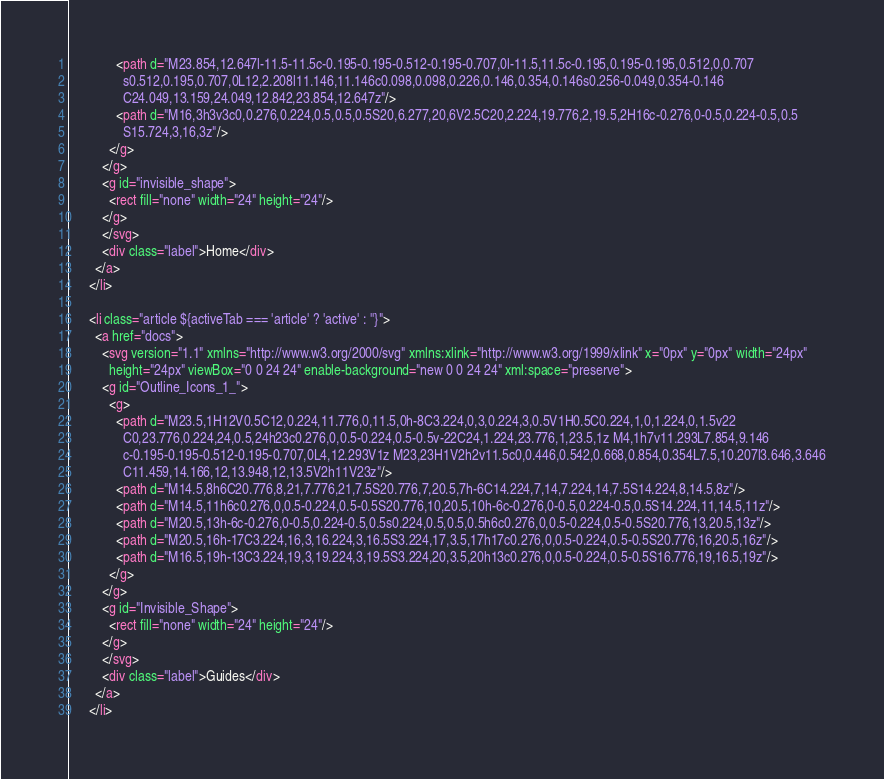<code> <loc_0><loc_0><loc_500><loc_500><_HTML_>              <path d="M23.854,12.647l-11.5-11.5c-0.195-0.195-0.512-0.195-0.707,0l-11.5,11.5c-0.195,0.195-0.195,0.512,0,0.707
                s0.512,0.195,0.707,0L12,2.208l11.146,11.146c0.098,0.098,0.226,0.146,0.354,0.146s0.256-0.049,0.354-0.146
                C24.049,13.159,24.049,12.842,23.854,12.647z"/>
              <path d="M16,3h3v3c0,0.276,0.224,0.5,0.5,0.5S20,6.277,20,6V2.5C20,2.224,19.776,2,19.5,2H16c-0.276,0-0.5,0.224-0.5,0.5
                S15.724,3,16,3z"/>
            </g>
          </g>
          <g id="invisible_shape">
            <rect fill="none" width="24" height="24"/>
          </g>
          </svg>
          <div class="label">Home</div>
        </a>
      </li>

      <li class="article ${activeTab === 'article' ? 'active' : ''}">
        <a href="docs">
          <svg version="1.1" xmlns="http://www.w3.org/2000/svg" xmlns:xlink="http://www.w3.org/1999/xlink" x="0px" y="0px" width="24px"
            height="24px" viewBox="0 0 24 24" enable-background="new 0 0 24 24" xml:space="preserve">
          <g id="Outline_Icons_1_">
            <g>
              <path d="M23.5,1H12V0.5C12,0.224,11.776,0,11.5,0h-8C3.224,0,3,0.224,3,0.5V1H0.5C0.224,1,0,1.224,0,1.5v22
                C0,23.776,0.224,24,0.5,24h23c0.276,0,0.5-0.224,0.5-0.5v-22C24,1.224,23.776,1,23.5,1z M4,1h7v11.293L7.854,9.146
                c-0.195-0.195-0.512-0.195-0.707,0L4,12.293V1z M23,23H1V2h2v11.5c0,0.446,0.542,0.668,0.854,0.354L7.5,10.207l3.646,3.646
                C11.459,14.166,12,13.948,12,13.5V2h11V23z"/>
              <path d="M14.5,8h6C20.776,8,21,7.776,21,7.5S20.776,7,20.5,7h-6C14.224,7,14,7.224,14,7.5S14.224,8,14.5,8z"/>
              <path d="M14.5,11h6c0.276,0,0.5-0.224,0.5-0.5S20.776,10,20.5,10h-6c-0.276,0-0.5,0.224-0.5,0.5S14.224,11,14.5,11z"/>
              <path d="M20.5,13h-6c-0.276,0-0.5,0.224-0.5,0.5s0.224,0.5,0.5,0.5h6c0.276,0,0.5-0.224,0.5-0.5S20.776,13,20.5,13z"/>
              <path d="M20.5,16h-17C3.224,16,3,16.224,3,16.5S3.224,17,3.5,17h17c0.276,0,0.5-0.224,0.5-0.5S20.776,16,20.5,16z"/>
              <path d="M16.5,19h-13C3.224,19,3,19.224,3,19.5S3.224,20,3.5,20h13c0.276,0,0.5-0.224,0.5-0.5S16.776,19,16.5,19z"/>
            </g>
          </g>
          <g id="Invisible_Shape">
            <rect fill="none" width="24" height="24"/>
          </g>
          </svg>
          <div class="label">Guides</div>
        </a>
      </li>
</code> 